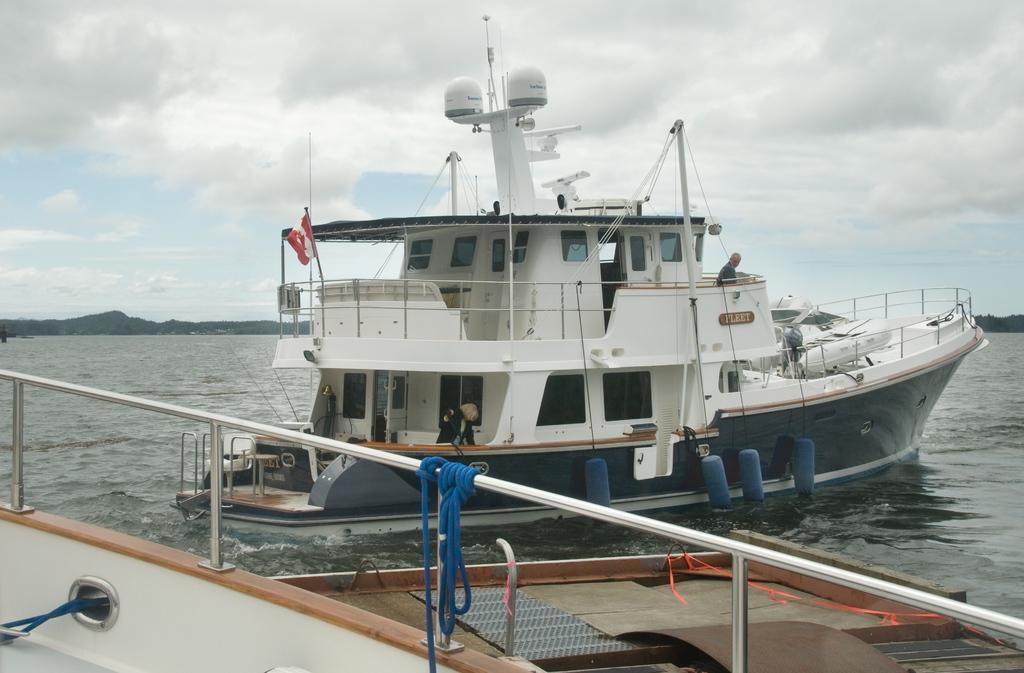Could you give a brief overview of what you see in this image? In this image we can see a ship in a large water body. We can also see the flag, ropes, poles, barriers and some people standing inside it. On the bottom of the image we can see some metal poles, ribbon and the ropes. On the backside we can see the hills and the sky which looks cloudy. 